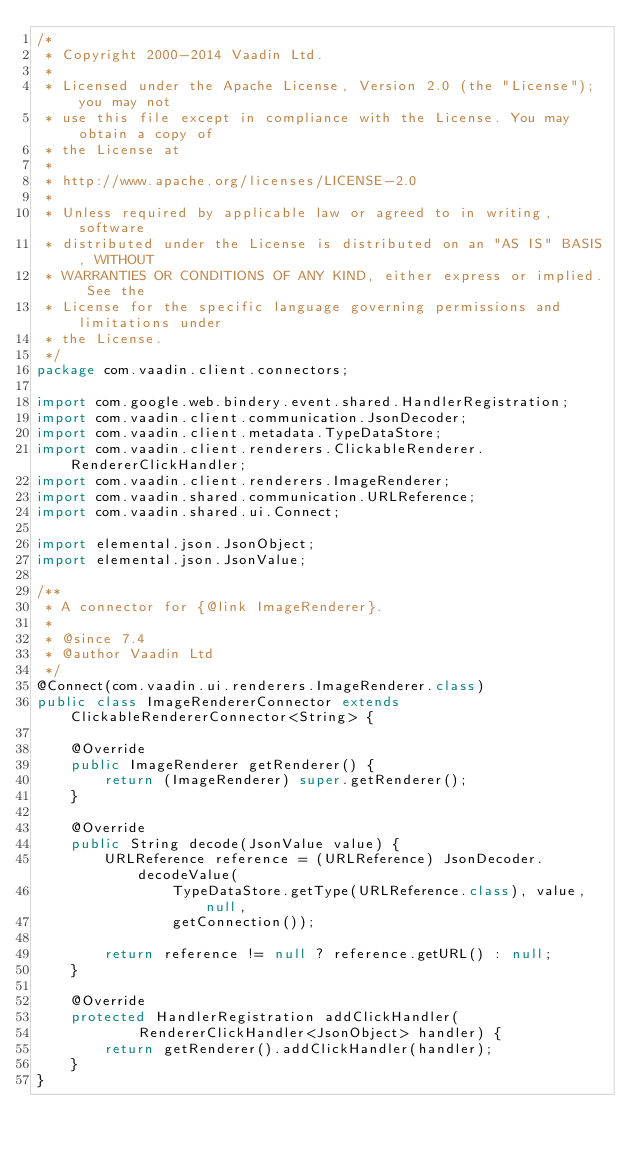<code> <loc_0><loc_0><loc_500><loc_500><_Java_>/*
 * Copyright 2000-2014 Vaadin Ltd.
 * 
 * Licensed under the Apache License, Version 2.0 (the "License"); you may not
 * use this file except in compliance with the License. You may obtain a copy of
 * the License at
 * 
 * http://www.apache.org/licenses/LICENSE-2.0
 * 
 * Unless required by applicable law or agreed to in writing, software
 * distributed under the License is distributed on an "AS IS" BASIS, WITHOUT
 * WARRANTIES OR CONDITIONS OF ANY KIND, either express or implied. See the
 * License for the specific language governing permissions and limitations under
 * the License.
 */
package com.vaadin.client.connectors;

import com.google.web.bindery.event.shared.HandlerRegistration;
import com.vaadin.client.communication.JsonDecoder;
import com.vaadin.client.metadata.TypeDataStore;
import com.vaadin.client.renderers.ClickableRenderer.RendererClickHandler;
import com.vaadin.client.renderers.ImageRenderer;
import com.vaadin.shared.communication.URLReference;
import com.vaadin.shared.ui.Connect;

import elemental.json.JsonObject;
import elemental.json.JsonValue;

/**
 * A connector for {@link ImageRenderer}.
 * 
 * @since 7.4
 * @author Vaadin Ltd
 */
@Connect(com.vaadin.ui.renderers.ImageRenderer.class)
public class ImageRendererConnector extends ClickableRendererConnector<String> {

    @Override
    public ImageRenderer getRenderer() {
        return (ImageRenderer) super.getRenderer();
    }

    @Override
    public String decode(JsonValue value) {
        URLReference reference = (URLReference) JsonDecoder.decodeValue(
                TypeDataStore.getType(URLReference.class), value, null,
                getConnection());

        return reference != null ? reference.getURL() : null;
    }

    @Override
    protected HandlerRegistration addClickHandler(
            RendererClickHandler<JsonObject> handler) {
        return getRenderer().addClickHandler(handler);
    }
}
</code> 